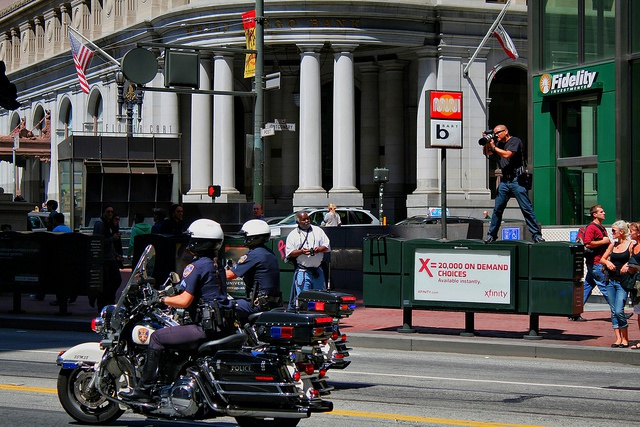Describe the objects in this image and their specific colors. I can see motorcycle in gray, black, navy, and lightgray tones, people in gray, black, navy, and lightgray tones, bench in gray, black, navy, and darkgreen tones, people in gray, black, navy, lightgray, and darkblue tones, and people in gray, black, navy, and blue tones in this image. 